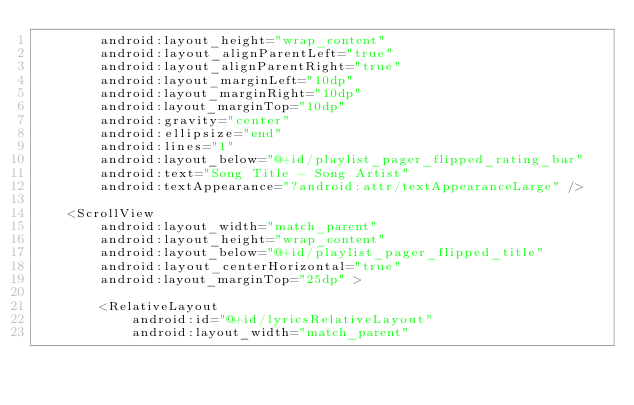<code> <loc_0><loc_0><loc_500><loc_500><_XML_>        android:layout_height="wrap_content"
        android:layout_alignParentLeft="true"
        android:layout_alignParentRight="true"
        android:layout_marginLeft="10dp"
        android:layout_marginRight="10dp"
        android:layout_marginTop="10dp"
        android:gravity="center"
        android:ellipsize="end"
        android:lines="1"
        android:layout_below="@+id/playlist_pager_flipped_rating_bar"
        android:text="Song Title - Song Artist"
        android:textAppearance="?android:attr/textAppearanceLarge" />

    <ScrollView
        android:layout_width="match_parent"
        android:layout_height="wrap_content"
        android:layout_below="@+id/playlist_pager_flipped_title"
        android:layout_centerHorizontal="true"
        android:layout_marginTop="25dp" >

        <RelativeLayout
            android:id="@+id/lyricsRelativeLayout"
            android:layout_width="match_parent"</code> 